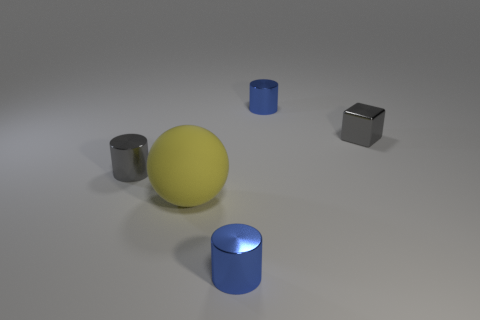Is there anything else that is the same size as the yellow rubber thing?
Your answer should be compact. No. Is the number of yellow rubber things to the left of the yellow matte sphere less than the number of purple cubes?
Your response must be concise. No. There is a blue object that is behind the large matte sphere; is it the same shape as the small thing that is on the left side of the large rubber sphere?
Give a very brief answer. Yes. What number of objects are tiny blue objects behind the big yellow sphere or small gray metallic objects?
Your answer should be compact. 3. There is a tiny gray shiny thing that is on the left side of the large yellow matte object that is in front of the shiny cube; are there any large rubber spheres in front of it?
Keep it short and to the point. Yes. Is the number of large yellow balls left of the big yellow rubber object less than the number of big rubber objects in front of the gray cylinder?
Your response must be concise. Yes. There is a cube that is the same material as the gray cylinder; what is its color?
Provide a succinct answer. Gray. What color is the tiny shiny cylinder to the right of the blue object in front of the large thing?
Make the answer very short. Blue. Are there any small metal cylinders of the same color as the tiny shiny cube?
Keep it short and to the point. Yes. There is a gray object that is the same size as the gray cylinder; what is its shape?
Your response must be concise. Cube. 